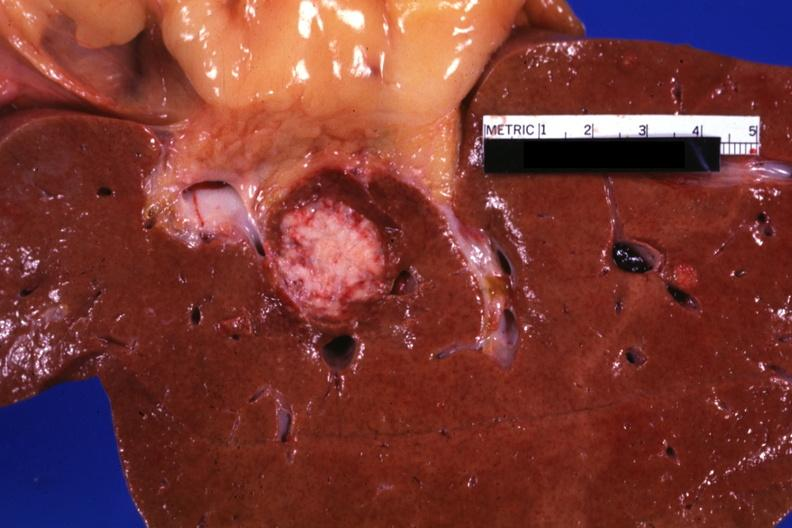what is present?
Answer the question using a single word or phrase. Liver 